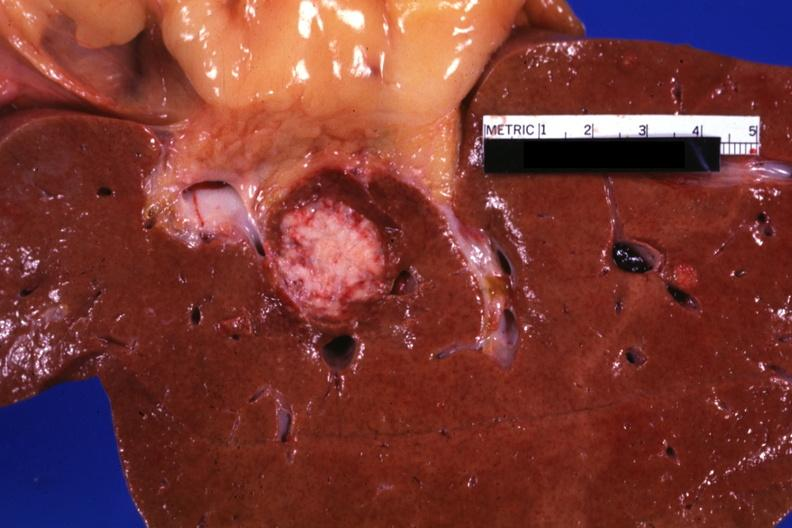what is present?
Answer the question using a single word or phrase. Liver 